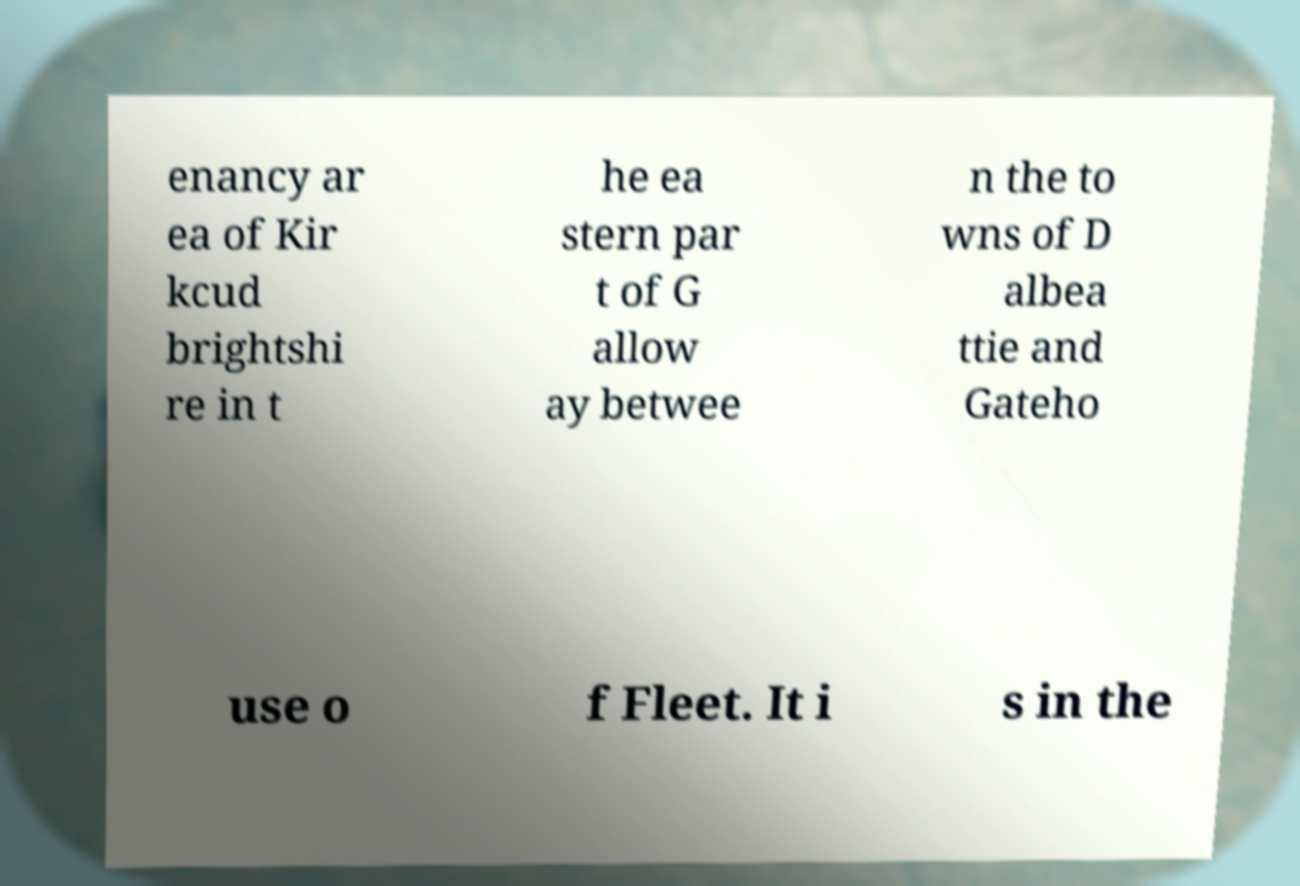For documentation purposes, I need the text within this image transcribed. Could you provide that? enancy ar ea of Kir kcud brightshi re in t he ea stern par t of G allow ay betwee n the to wns of D albea ttie and Gateho use o f Fleet. It i s in the 